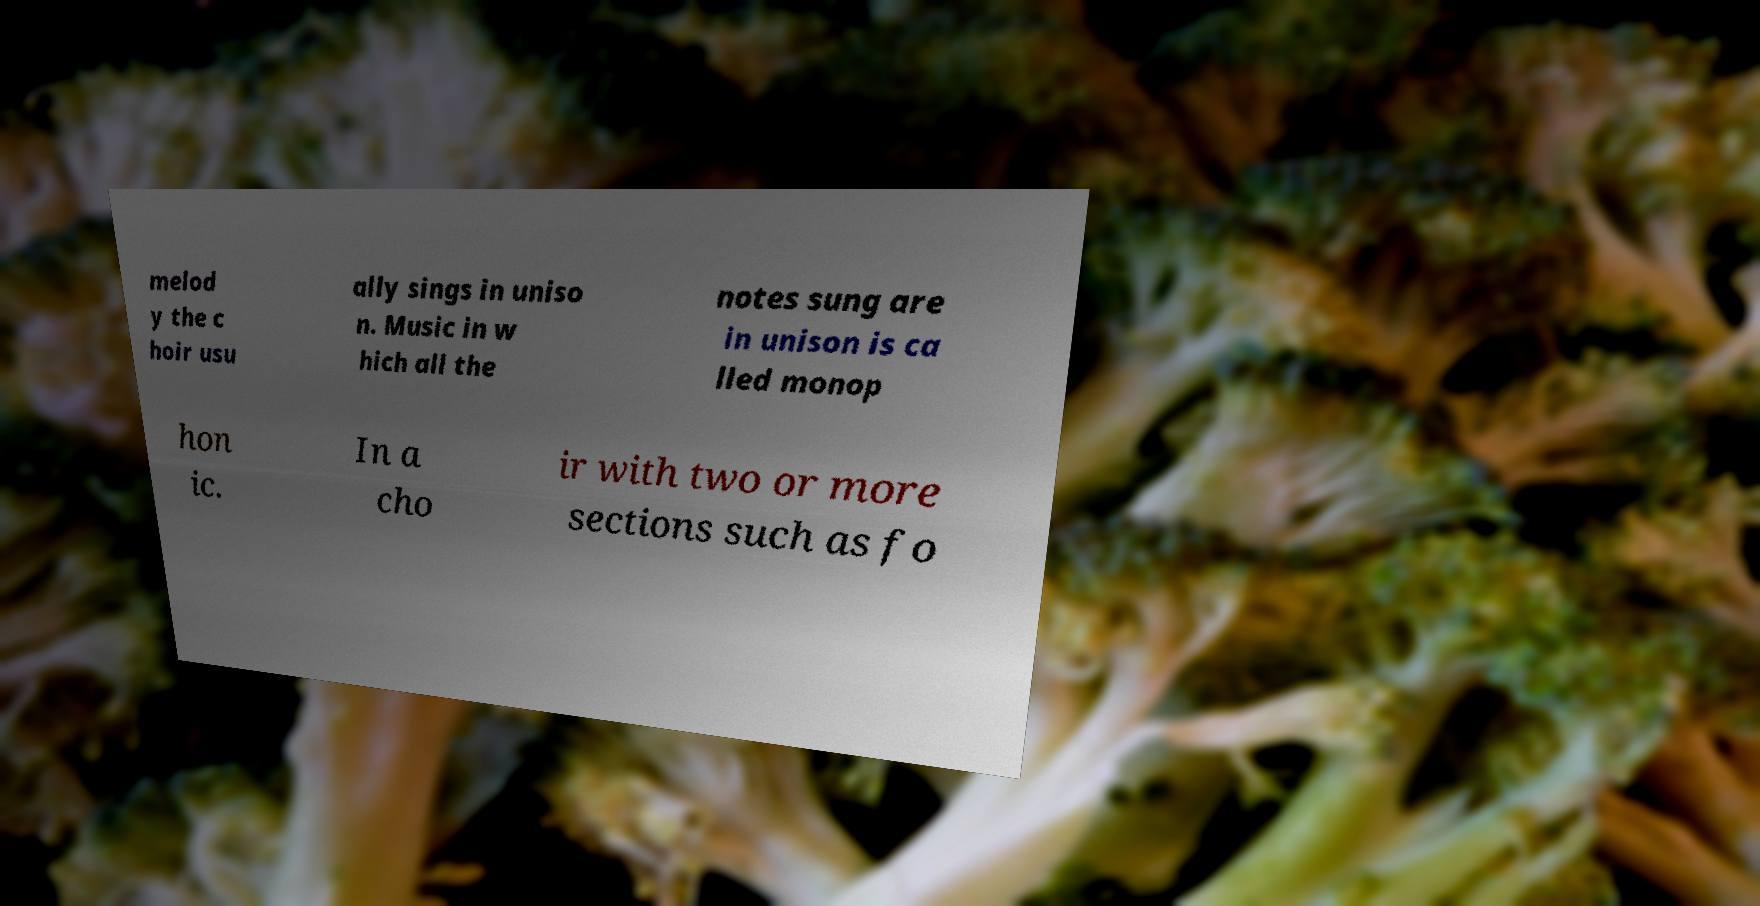Could you extract and type out the text from this image? melod y the c hoir usu ally sings in uniso n. Music in w hich all the notes sung are in unison is ca lled monop hon ic. In a cho ir with two or more sections such as fo 